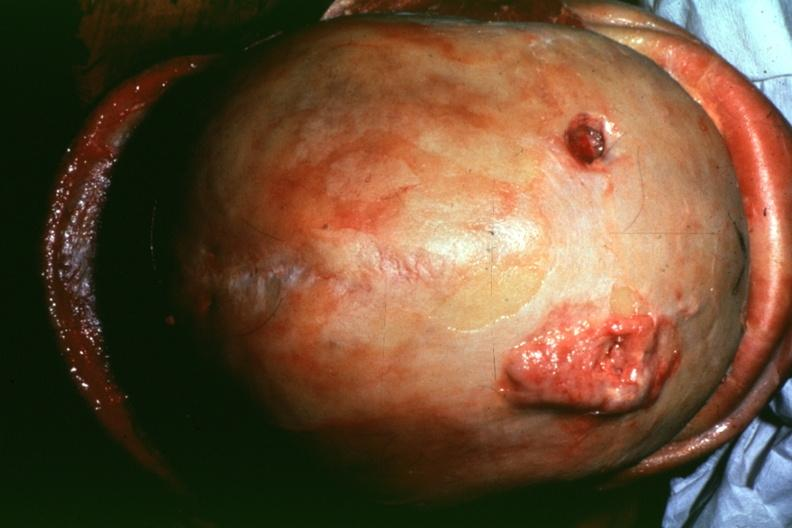what is present?
Answer the question using a single word or phrase. Bone, calvarium 